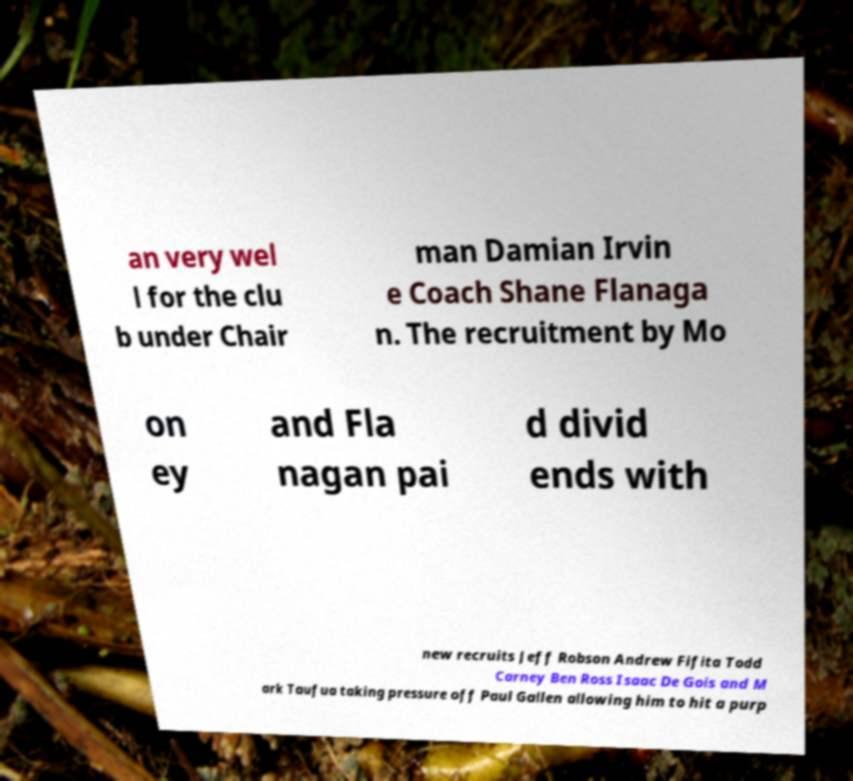Could you extract and type out the text from this image? an very wel l for the clu b under Chair man Damian Irvin e Coach Shane Flanaga n. The recruitment by Mo on ey and Fla nagan pai d divid ends with new recruits Jeff Robson Andrew Fifita Todd Carney Ben Ross Isaac De Gois and M ark Taufua taking pressure off Paul Gallen allowing him to hit a purp 